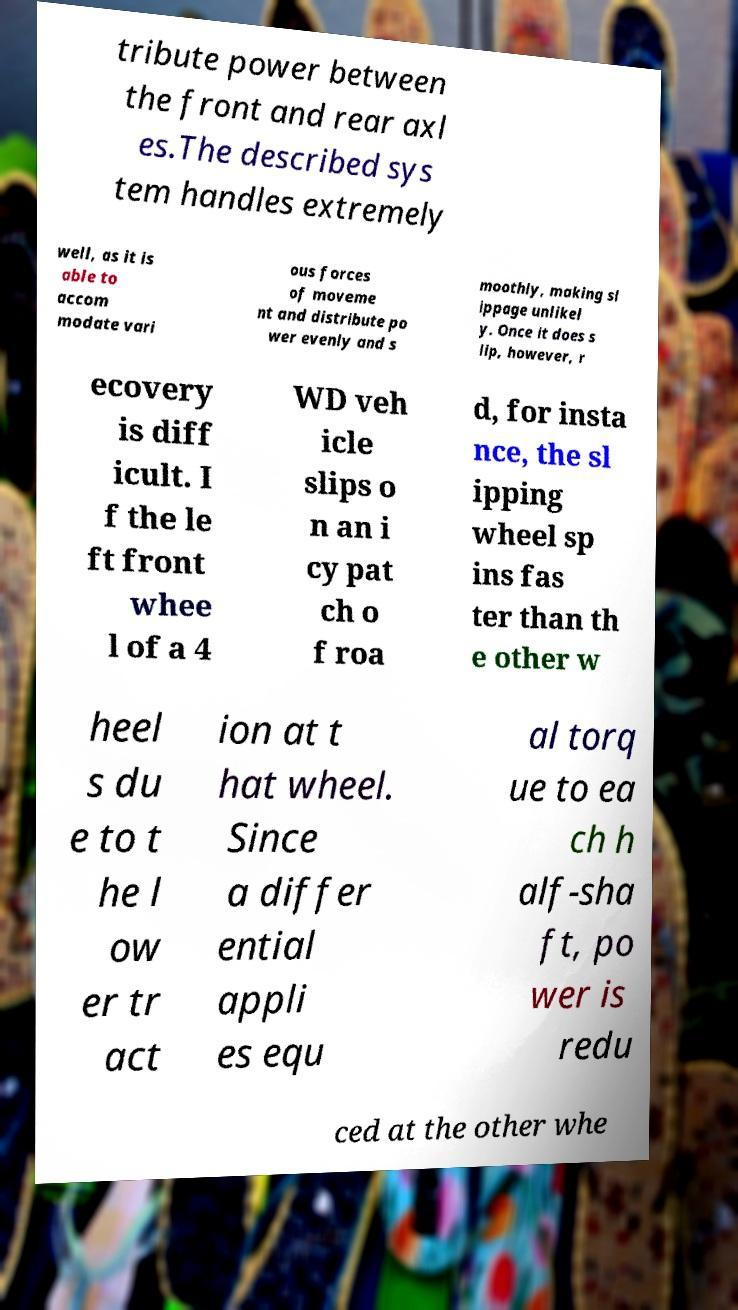Please identify and transcribe the text found in this image. tribute power between the front and rear axl es.The described sys tem handles extremely well, as it is able to accom modate vari ous forces of moveme nt and distribute po wer evenly and s moothly, making sl ippage unlikel y. Once it does s lip, however, r ecovery is diff icult. I f the le ft front whee l of a 4 WD veh icle slips o n an i cy pat ch o f roa d, for insta nce, the sl ipping wheel sp ins fas ter than th e other w heel s du e to t he l ow er tr act ion at t hat wheel. Since a differ ential appli es equ al torq ue to ea ch h alf-sha ft, po wer is redu ced at the other whe 